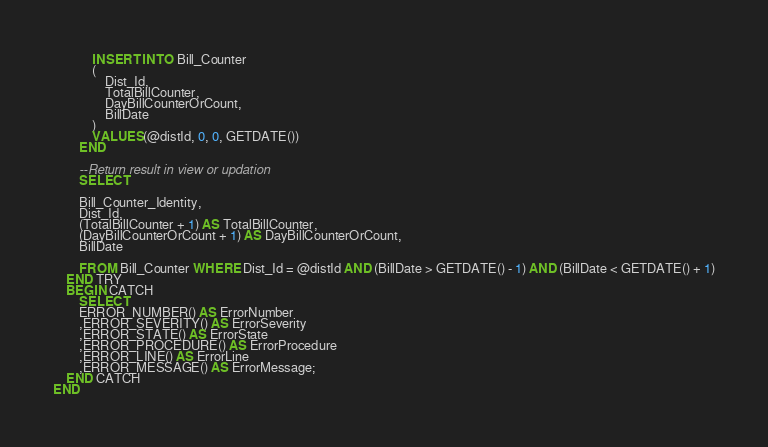Convert code to text. <code><loc_0><loc_0><loc_500><loc_500><_SQL_>			INSERT INTO Bill_Counter
			(
				Dist_Id,
				TotalBillCounter,
				DayBillCounterOrCount,
				BillDate
			)
			VALUES(@distId, 0, 0, GETDATE())
		END

		--Return result in view or updation
		SELECT 
		
		Bill_Counter_Identity,
		Dist_Id,
		(TotalBillCounter + 1) AS TotalBillCounter,
		(DayBillCounterOrCount + 1) AS DayBillCounterOrCount,
		BillDate

		FROM Bill_Counter WHERE Dist_Id = @distId AND (BillDate > GETDATE() - 1) AND (BillDate < GETDATE() + 1)
	END TRY
	BEGIN CATCH
		SELECT  
		ERROR_NUMBER() AS ErrorNumber  
		,ERROR_SEVERITY() AS ErrorSeverity  
		,ERROR_STATE() AS ErrorState  
		,ERROR_PROCEDURE() AS ErrorProcedure  
		,ERROR_LINE() AS ErrorLine  
		,ERROR_MESSAGE() AS ErrorMessage;  
	END CATCH
END

</code> 